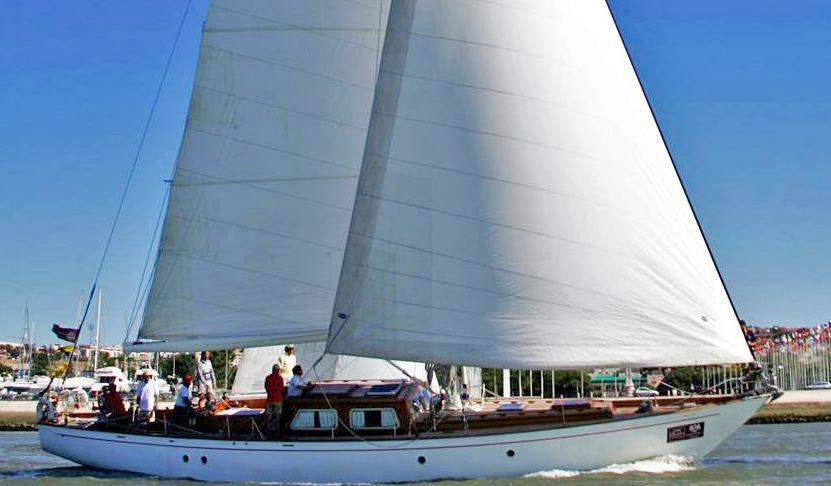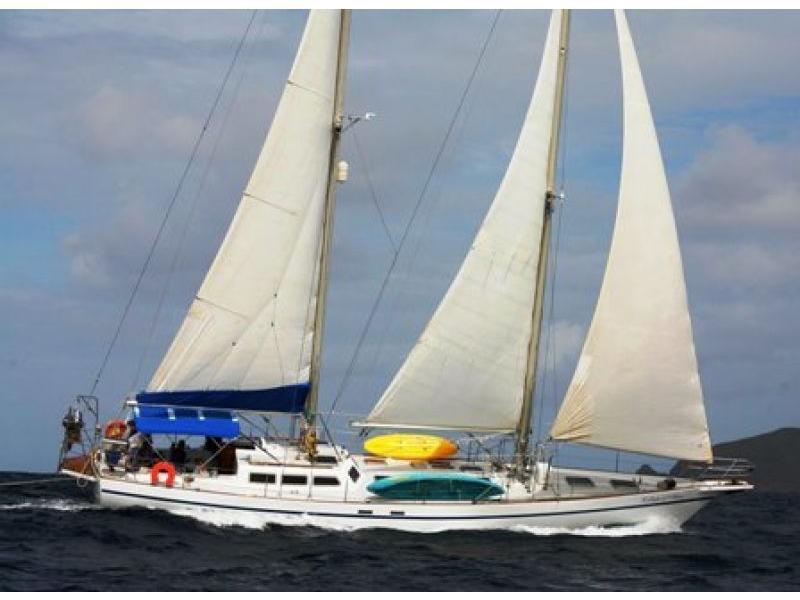The first image is the image on the left, the second image is the image on the right. Analyze the images presented: Is the assertion "A sailboat with three white sails is tilted sideways towards the water." valid? Answer yes or no. Yes. 